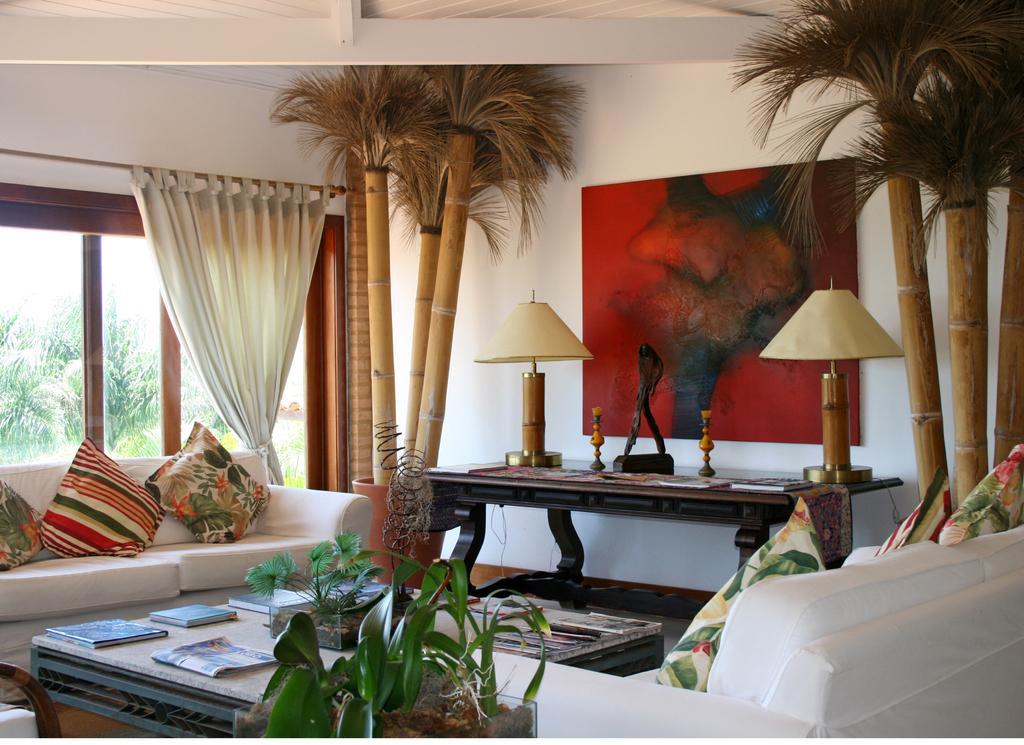Could you give a brief overview of what you see in this image? A picture inside of a room. This is window with curtains. Outside of this window we can able to see trees. A picture on wall. On this table there are lantern lamps and sculpture. This is a white couch with pillows. On this table there are books. This is plant. 